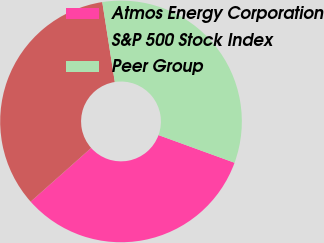Convert chart. <chart><loc_0><loc_0><loc_500><loc_500><pie_chart><fcel>Atmos Energy Corporation<fcel>S&P 500 Stock Index<fcel>Peer Group<nl><fcel>32.89%<fcel>34.08%<fcel>33.03%<nl></chart> 